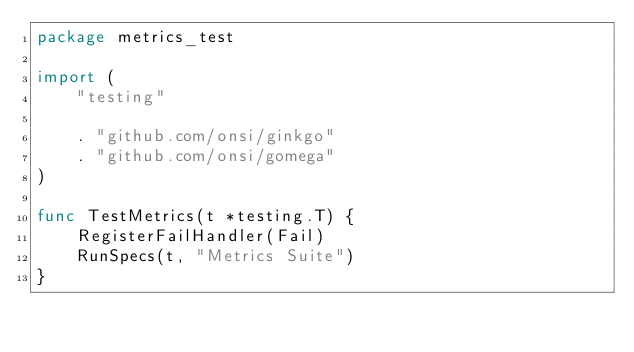<code> <loc_0><loc_0><loc_500><loc_500><_Go_>package metrics_test

import (
	"testing"

	. "github.com/onsi/ginkgo"
	. "github.com/onsi/gomega"
)

func TestMetrics(t *testing.T) {
	RegisterFailHandler(Fail)
	RunSpecs(t, "Metrics Suite")
}
</code> 